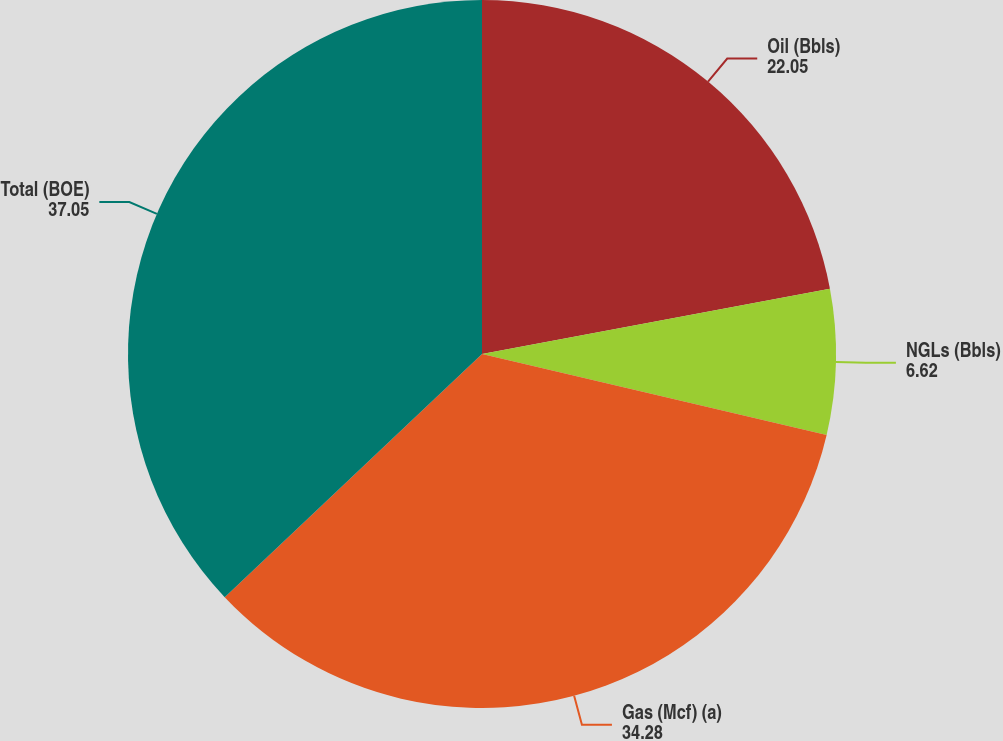Convert chart to OTSL. <chart><loc_0><loc_0><loc_500><loc_500><pie_chart><fcel>Oil (Bbls)<fcel>NGLs (Bbls)<fcel>Gas (Mcf) (a)<fcel>Total (BOE)<nl><fcel>22.05%<fcel>6.62%<fcel>34.28%<fcel>37.05%<nl></chart> 